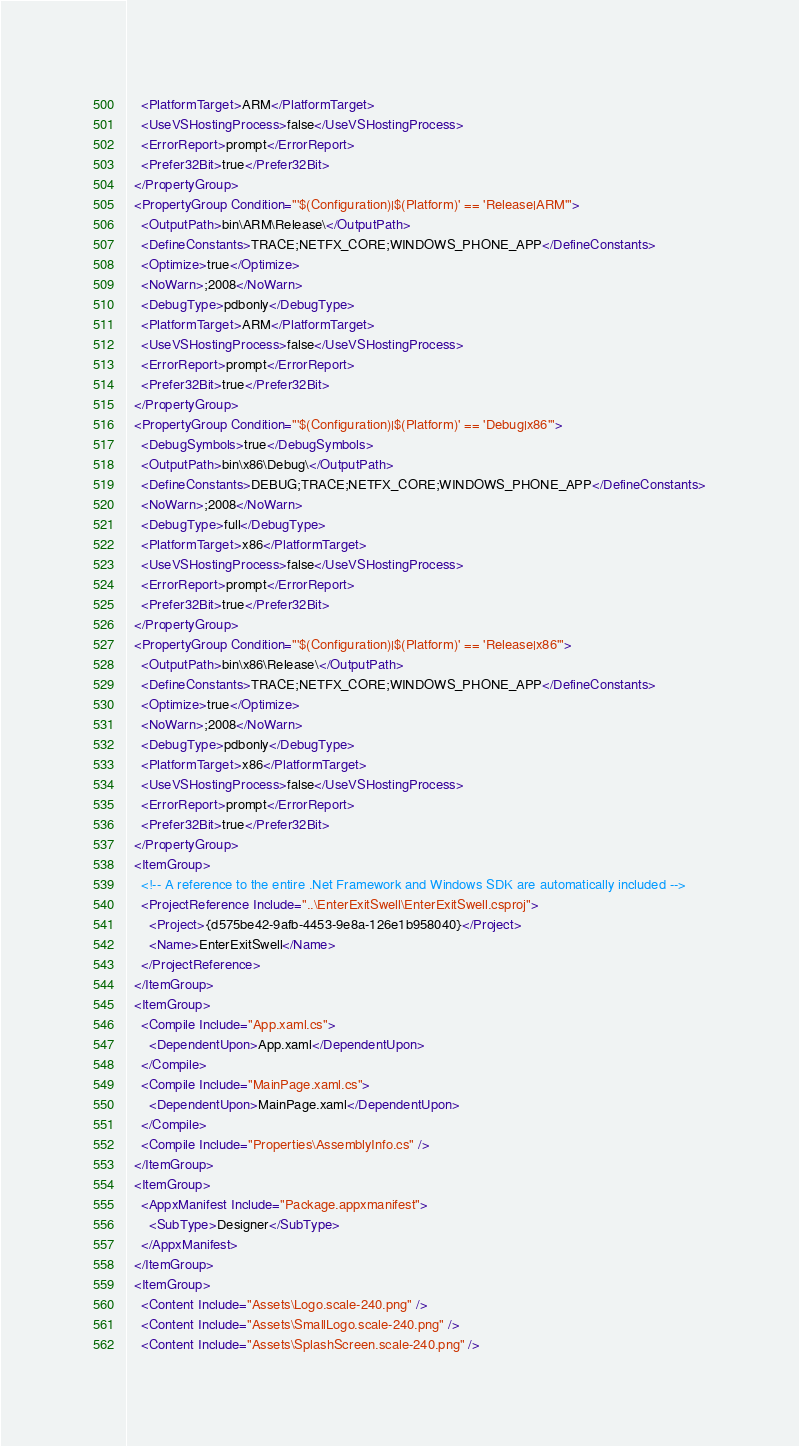<code> <loc_0><loc_0><loc_500><loc_500><_XML_>    <PlatformTarget>ARM</PlatformTarget>
    <UseVSHostingProcess>false</UseVSHostingProcess>
    <ErrorReport>prompt</ErrorReport>
    <Prefer32Bit>true</Prefer32Bit>
  </PropertyGroup>
  <PropertyGroup Condition="'$(Configuration)|$(Platform)' == 'Release|ARM'">
    <OutputPath>bin\ARM\Release\</OutputPath>
    <DefineConstants>TRACE;NETFX_CORE;WINDOWS_PHONE_APP</DefineConstants>
    <Optimize>true</Optimize>
    <NoWarn>;2008</NoWarn>
    <DebugType>pdbonly</DebugType>
    <PlatformTarget>ARM</PlatformTarget>
    <UseVSHostingProcess>false</UseVSHostingProcess>
    <ErrorReport>prompt</ErrorReport>
    <Prefer32Bit>true</Prefer32Bit>
  </PropertyGroup>
  <PropertyGroup Condition="'$(Configuration)|$(Platform)' == 'Debug|x86'">
    <DebugSymbols>true</DebugSymbols>
    <OutputPath>bin\x86\Debug\</OutputPath>
    <DefineConstants>DEBUG;TRACE;NETFX_CORE;WINDOWS_PHONE_APP</DefineConstants>
    <NoWarn>;2008</NoWarn>
    <DebugType>full</DebugType>
    <PlatformTarget>x86</PlatformTarget>
    <UseVSHostingProcess>false</UseVSHostingProcess>
    <ErrorReport>prompt</ErrorReport>
    <Prefer32Bit>true</Prefer32Bit>
  </PropertyGroup>
  <PropertyGroup Condition="'$(Configuration)|$(Platform)' == 'Release|x86'">
    <OutputPath>bin\x86\Release\</OutputPath>
    <DefineConstants>TRACE;NETFX_CORE;WINDOWS_PHONE_APP</DefineConstants>
    <Optimize>true</Optimize>
    <NoWarn>;2008</NoWarn>
    <DebugType>pdbonly</DebugType>
    <PlatformTarget>x86</PlatformTarget>
    <UseVSHostingProcess>false</UseVSHostingProcess>
    <ErrorReport>prompt</ErrorReport>
    <Prefer32Bit>true</Prefer32Bit>
  </PropertyGroup>
  <ItemGroup>
    <!-- A reference to the entire .Net Framework and Windows SDK are automatically included -->
    <ProjectReference Include="..\EnterExitSwell\EnterExitSwell.csproj">
      <Project>{d575be42-9afb-4453-9e8a-126e1b958040}</Project>
      <Name>EnterExitSwell</Name>
    </ProjectReference>
  </ItemGroup>
  <ItemGroup>
    <Compile Include="App.xaml.cs">
      <DependentUpon>App.xaml</DependentUpon>
    </Compile>
    <Compile Include="MainPage.xaml.cs">
      <DependentUpon>MainPage.xaml</DependentUpon>
    </Compile>
    <Compile Include="Properties\AssemblyInfo.cs" />
  </ItemGroup>
  <ItemGroup>
    <AppxManifest Include="Package.appxmanifest">
      <SubType>Designer</SubType>
    </AppxManifest>
  </ItemGroup>
  <ItemGroup>
    <Content Include="Assets\Logo.scale-240.png" />
    <Content Include="Assets\SmallLogo.scale-240.png" />
    <Content Include="Assets\SplashScreen.scale-240.png" /></code> 